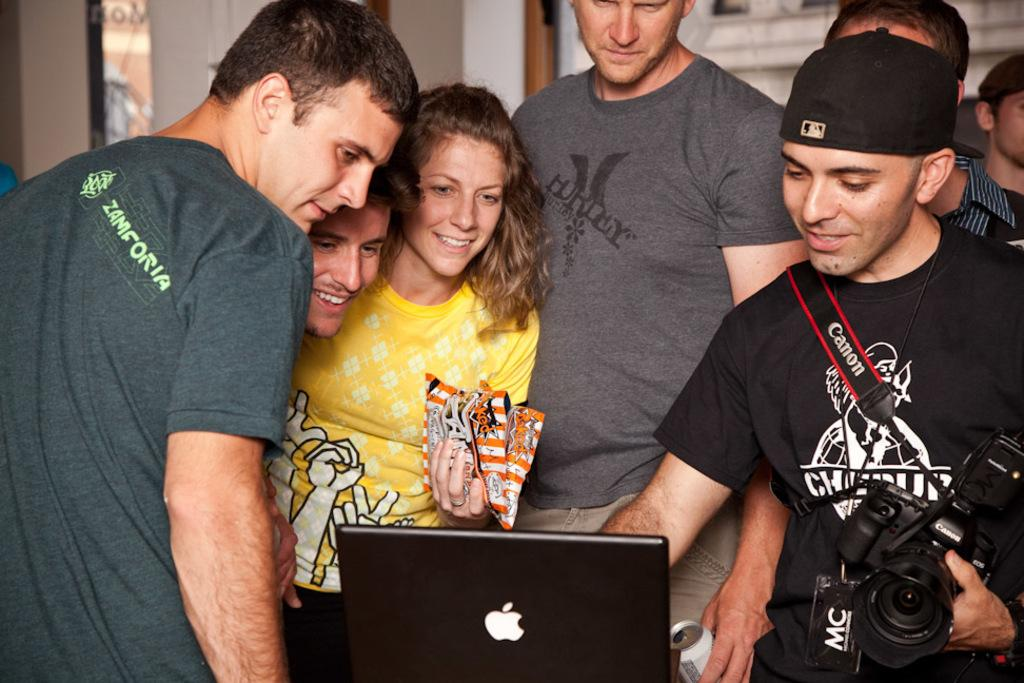How many people are in the image? There are persons in the image. What is one person doing in the image? One person is holding a camera. What is the facial expression of the persons in the image? The persons are smiling. What electronic device is present in the image? There is a laptop in the image. What type of sign can be seen hanging from the ceiling in the image? There is no sign visible in the image; it only features persons, a camera, and a laptop. What is the mindset of the persons in the image? The provided facts do not give any information about the mindset of the persons in the image. 